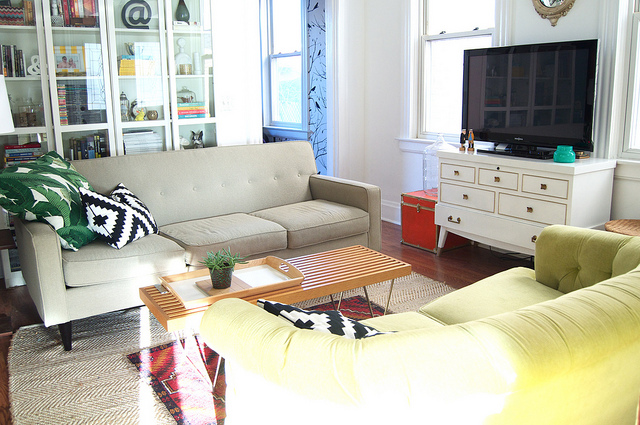What color is the vase on the right side of the white entertainment center? The vase on the right side of the white entertainment center is a vibrant turquoise, providing a refreshing pop of color that contrasts beautifully with the neutral tones of the room. 